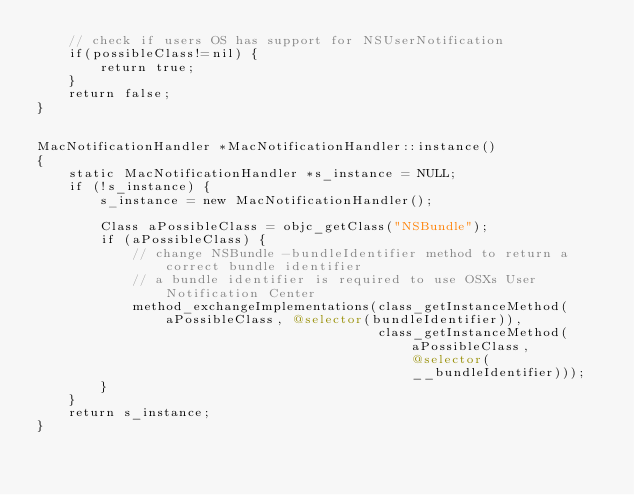<code> <loc_0><loc_0><loc_500><loc_500><_ObjectiveC_>    // check if users OS has support for NSUserNotification
    if(possibleClass!=nil) {
        return true;
    }
    return false;
}


MacNotificationHandler *MacNotificationHandler::instance()
{
    static MacNotificationHandler *s_instance = NULL;
    if (!s_instance) {
        s_instance = new MacNotificationHandler();
        
        Class aPossibleClass = objc_getClass("NSBundle");
        if (aPossibleClass) {
            // change NSBundle -bundleIdentifier method to return a correct bundle identifier
            // a bundle identifier is required to use OSXs User Notification Center
            method_exchangeImplementations(class_getInstanceMethod(aPossibleClass, @selector(bundleIdentifier)),
                                           class_getInstanceMethod(aPossibleClass, @selector(__bundleIdentifier)));
        }
    }
    return s_instance;
}
</code> 